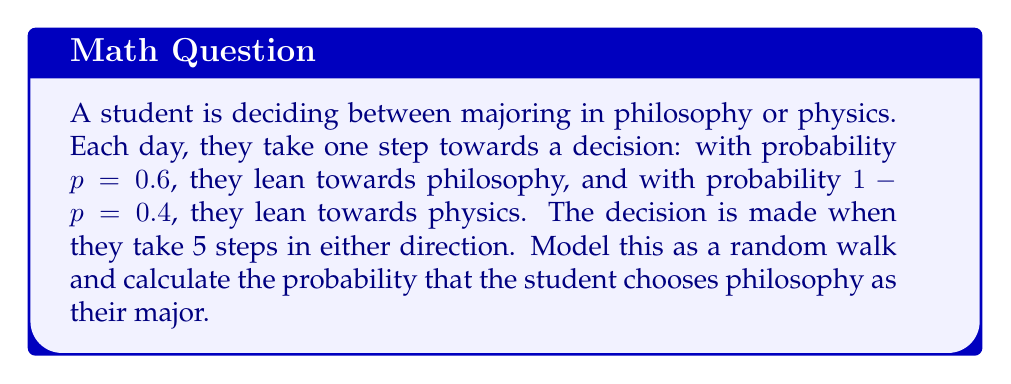What is the answer to this math problem? Let's approach this step-by-step:

1) This scenario can be modeled as a random walk on a 1-dimensional line, where:
   - Moving right (towards +5) represents leaning towards philosophy
   - Moving left (towards -5) represents leaning towards physics

2) We need to find the probability of reaching +5 before reaching -5.

3) For a general random walk with probability $p$ of moving right and $1-p$ of moving left, the probability of reaching a point $a$ before reaching point $-b$ is given by:

   $$P(\text{reach } a \text{ before } -b) = \frac{1 - (\frac{1-p}{p})^b}{1 - (\frac{1-p}{p})^{a+b}}$$

4) In our case, $a = b = 5$, and $p = 0.6$. Let's substitute these values:

   $$P(\text{choose philosophy}) = \frac{1 - (\frac{0.4}{0.6})^5}{1 - (\frac{0.4}{0.6})^{10}}$$

5) Let's calculate this step-by-step:
   
   $$\frac{0.4}{0.6} = \frac{2}{3}$$
   
   $$(\frac{2}{3})^5 \approx 0.1316$$
   
   $$(\frac{2}{3})^{10} \approx 0.0173$$

6) Now, let's substitute these values:

   $$P(\text{choose philosophy}) = \frac{1 - 0.1316}{1 - 0.0173} \approx \frac{0.8684}{0.9827} \approx 0.8835$$

7) Therefore, the probability that the student chooses philosophy as their major is approximately 0.8835 or about 88.35%.
Answer: 0.8835 